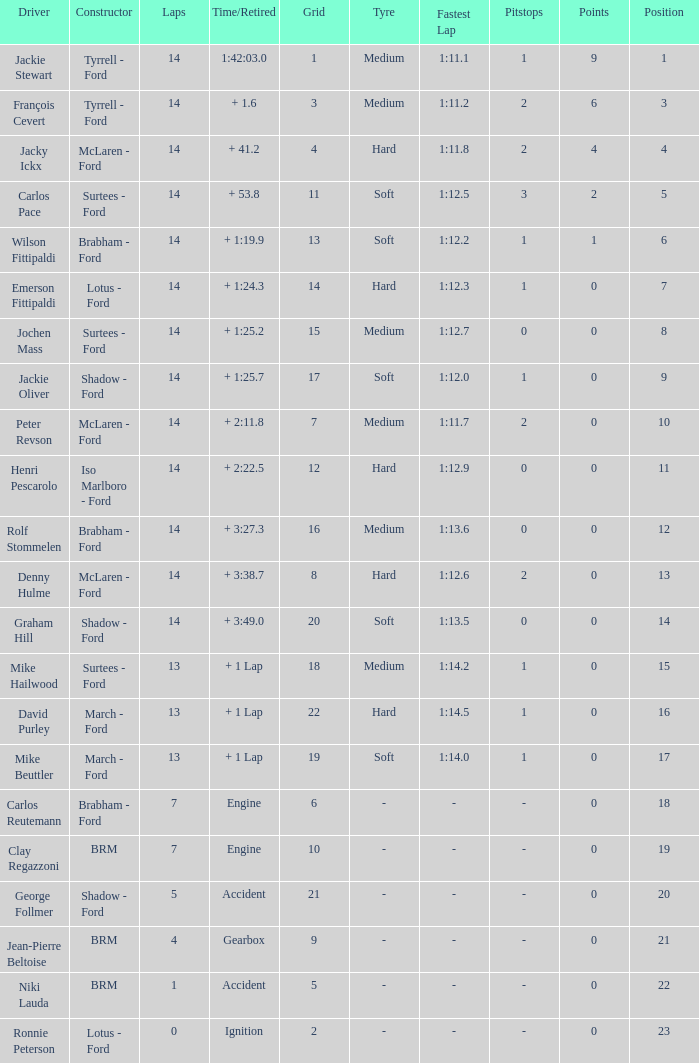What is the low lap total for a grid larger than 16 and has a Time/Retired of + 3:27.3? None. 